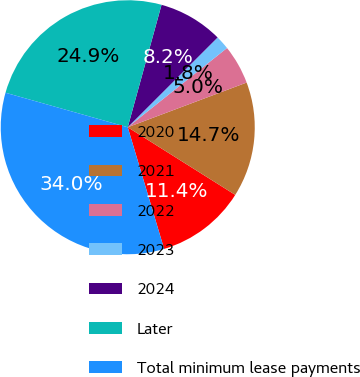Convert chart. <chart><loc_0><loc_0><loc_500><loc_500><pie_chart><fcel>2020<fcel>2021<fcel>2022<fcel>2023<fcel>2024<fcel>Later<fcel>Total minimum lease payments<nl><fcel>11.44%<fcel>14.66%<fcel>5.0%<fcel>1.77%<fcel>8.22%<fcel>24.91%<fcel>34.0%<nl></chart> 